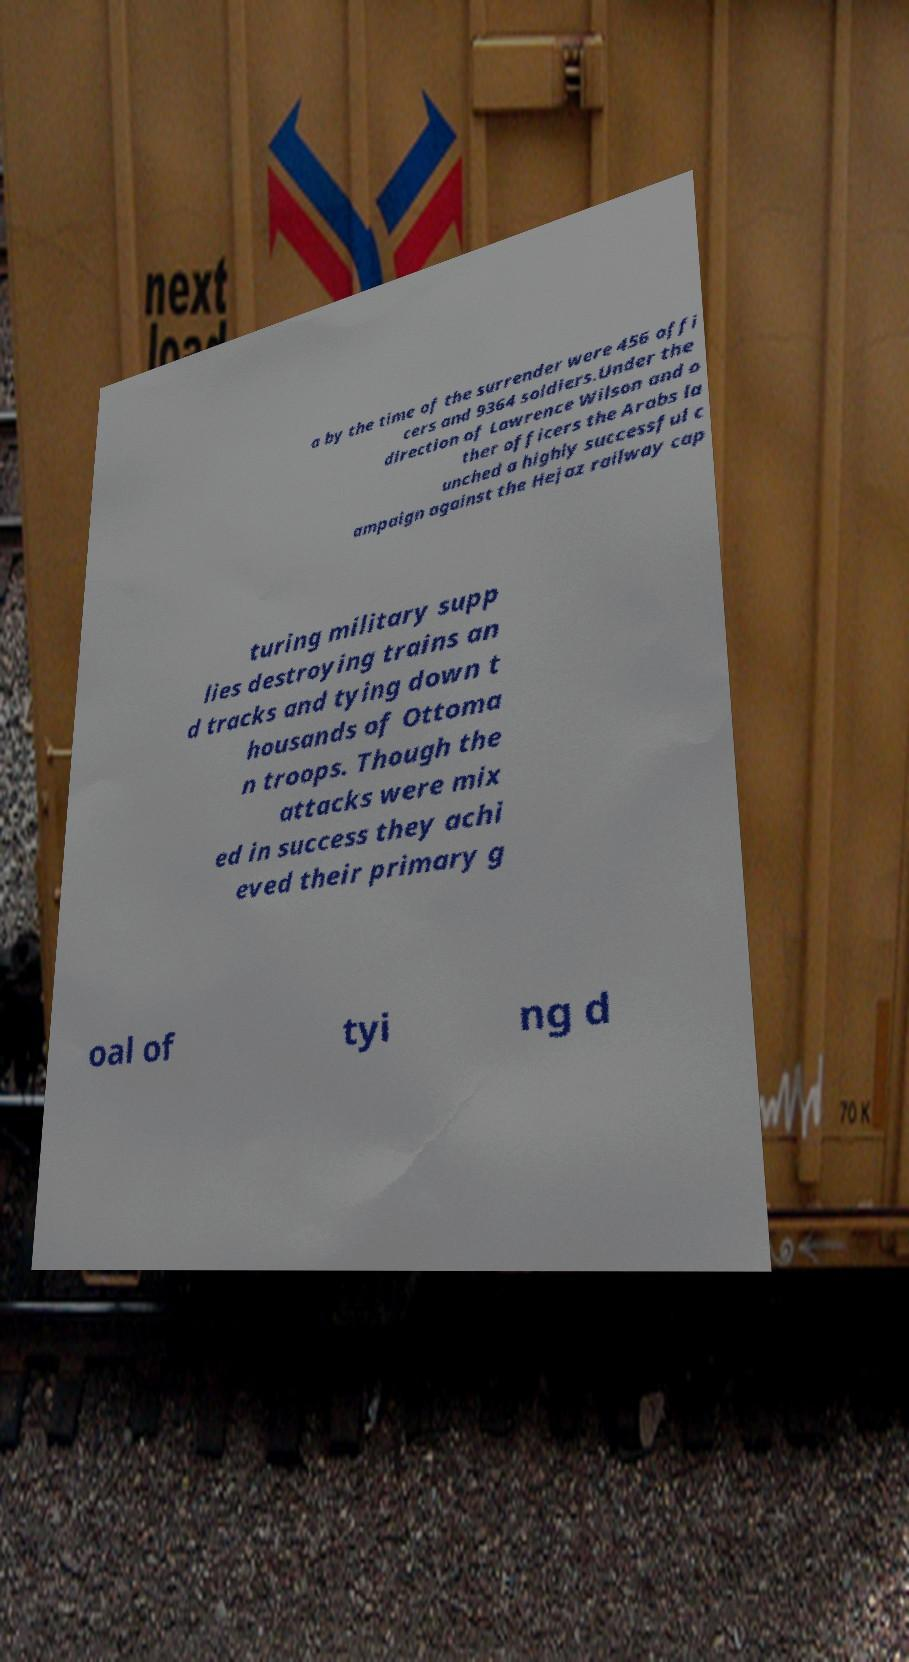For documentation purposes, I need the text within this image transcribed. Could you provide that? a by the time of the surrender were 456 offi cers and 9364 soldiers.Under the direction of Lawrence Wilson and o ther officers the Arabs la unched a highly successful c ampaign against the Hejaz railway cap turing military supp lies destroying trains an d tracks and tying down t housands of Ottoma n troops. Though the attacks were mix ed in success they achi eved their primary g oal of tyi ng d 